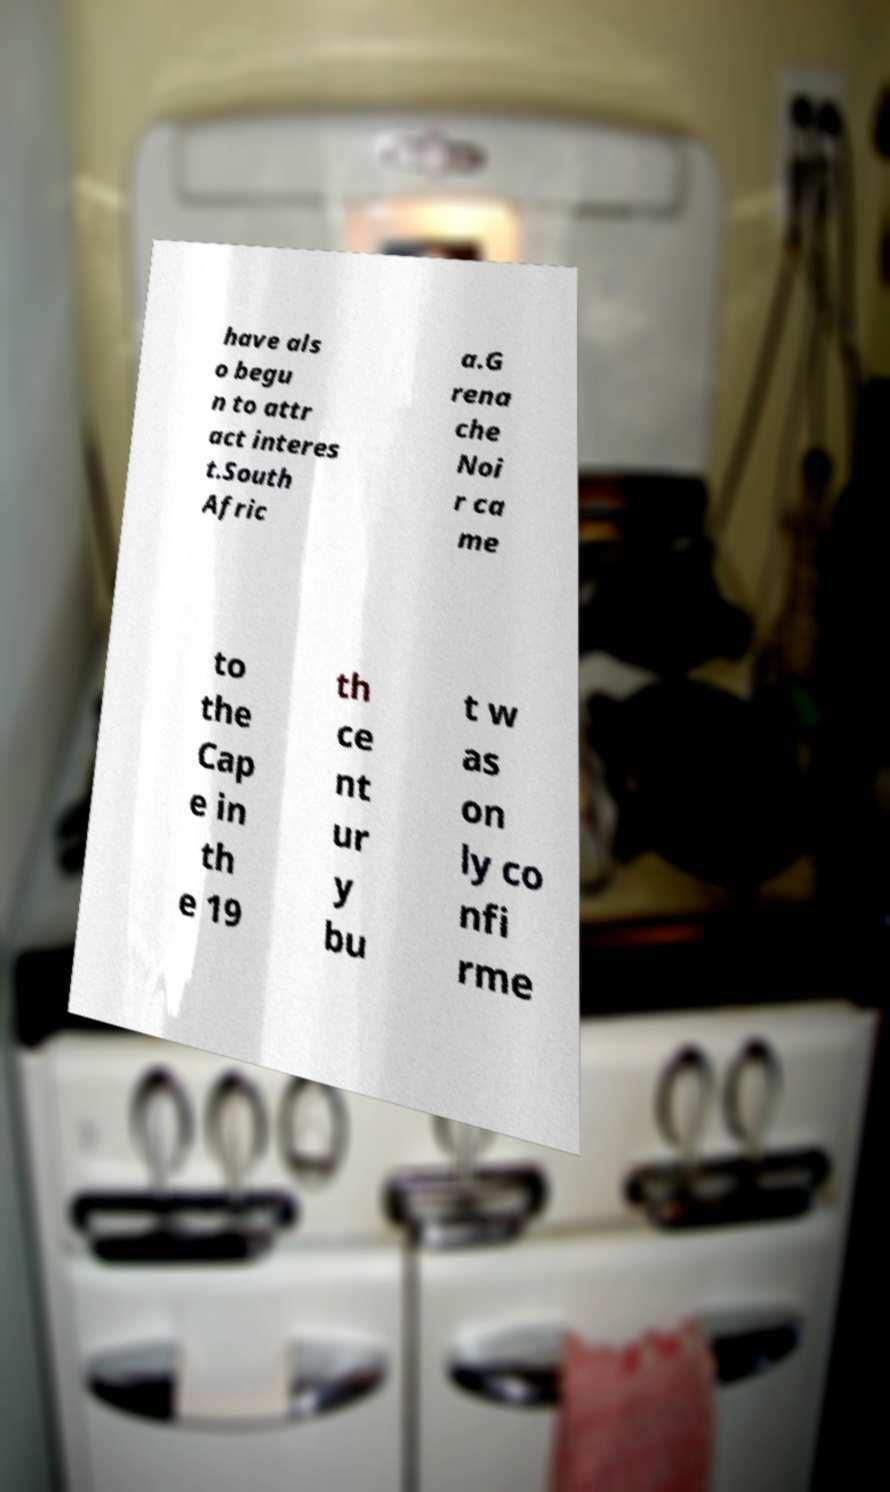Can you read and provide the text displayed in the image?This photo seems to have some interesting text. Can you extract and type it out for me? have als o begu n to attr act interes t.South Afric a.G rena che Noi r ca me to the Cap e in th e 19 th ce nt ur y bu t w as on ly co nfi rme 